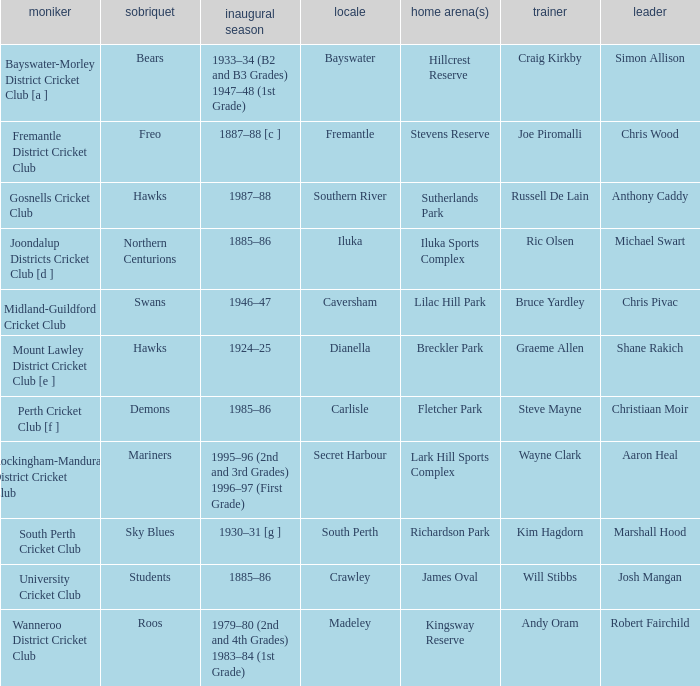What is the code nickname where Steve Mayne is the coach? Demons. 